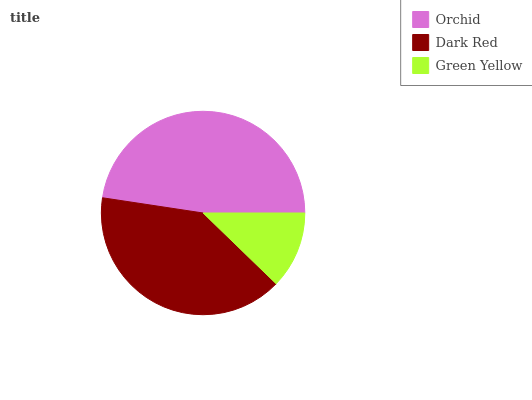Is Green Yellow the minimum?
Answer yes or no. Yes. Is Orchid the maximum?
Answer yes or no. Yes. Is Dark Red the minimum?
Answer yes or no. No. Is Dark Red the maximum?
Answer yes or no. No. Is Orchid greater than Dark Red?
Answer yes or no. Yes. Is Dark Red less than Orchid?
Answer yes or no. Yes. Is Dark Red greater than Orchid?
Answer yes or no. No. Is Orchid less than Dark Red?
Answer yes or no. No. Is Dark Red the high median?
Answer yes or no. Yes. Is Dark Red the low median?
Answer yes or no. Yes. Is Green Yellow the high median?
Answer yes or no. No. Is Orchid the low median?
Answer yes or no. No. 